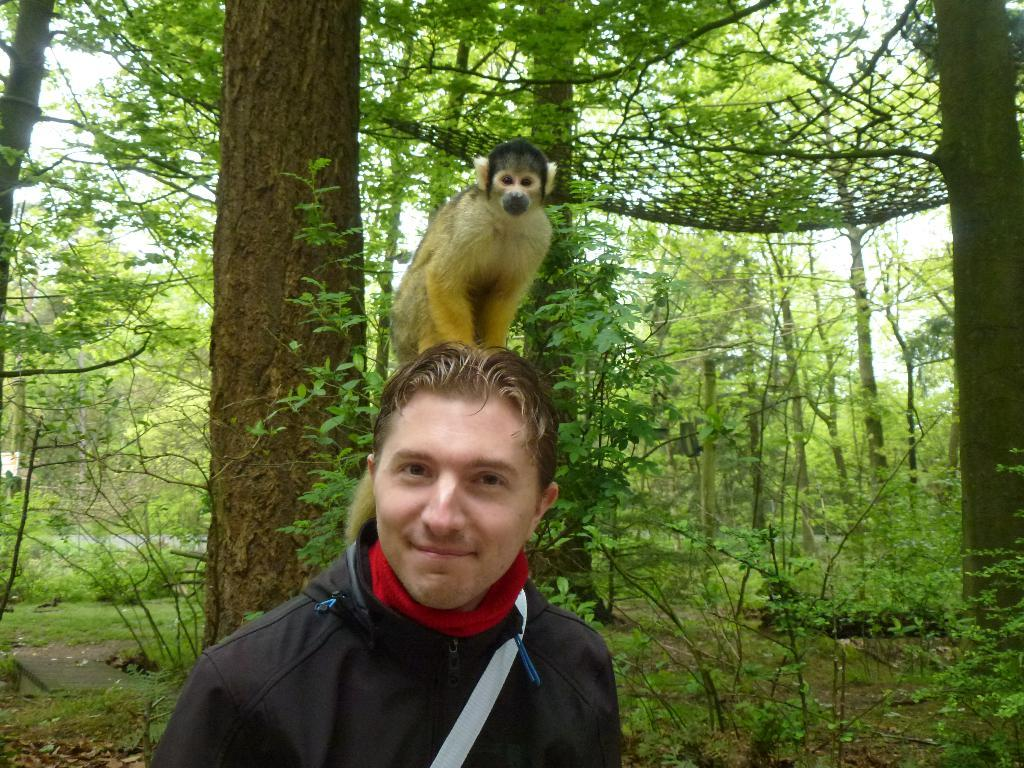Who is the main subject in the center of the image? There is a man in the center of the image. What is on the man's head? There is a monkey on the man's head. What can be seen in the background of the image? There is a net in the background of the image. How is the net attached to the trees? The net is fixed to trees. What type of knot is used to secure the monkey to the man's head in the image? There is no knot used to secure the monkey to the man's head in the image; the monkey is simply sitting on his head. Who is the servant attending to the man in the image? There is no servant present in the image. 